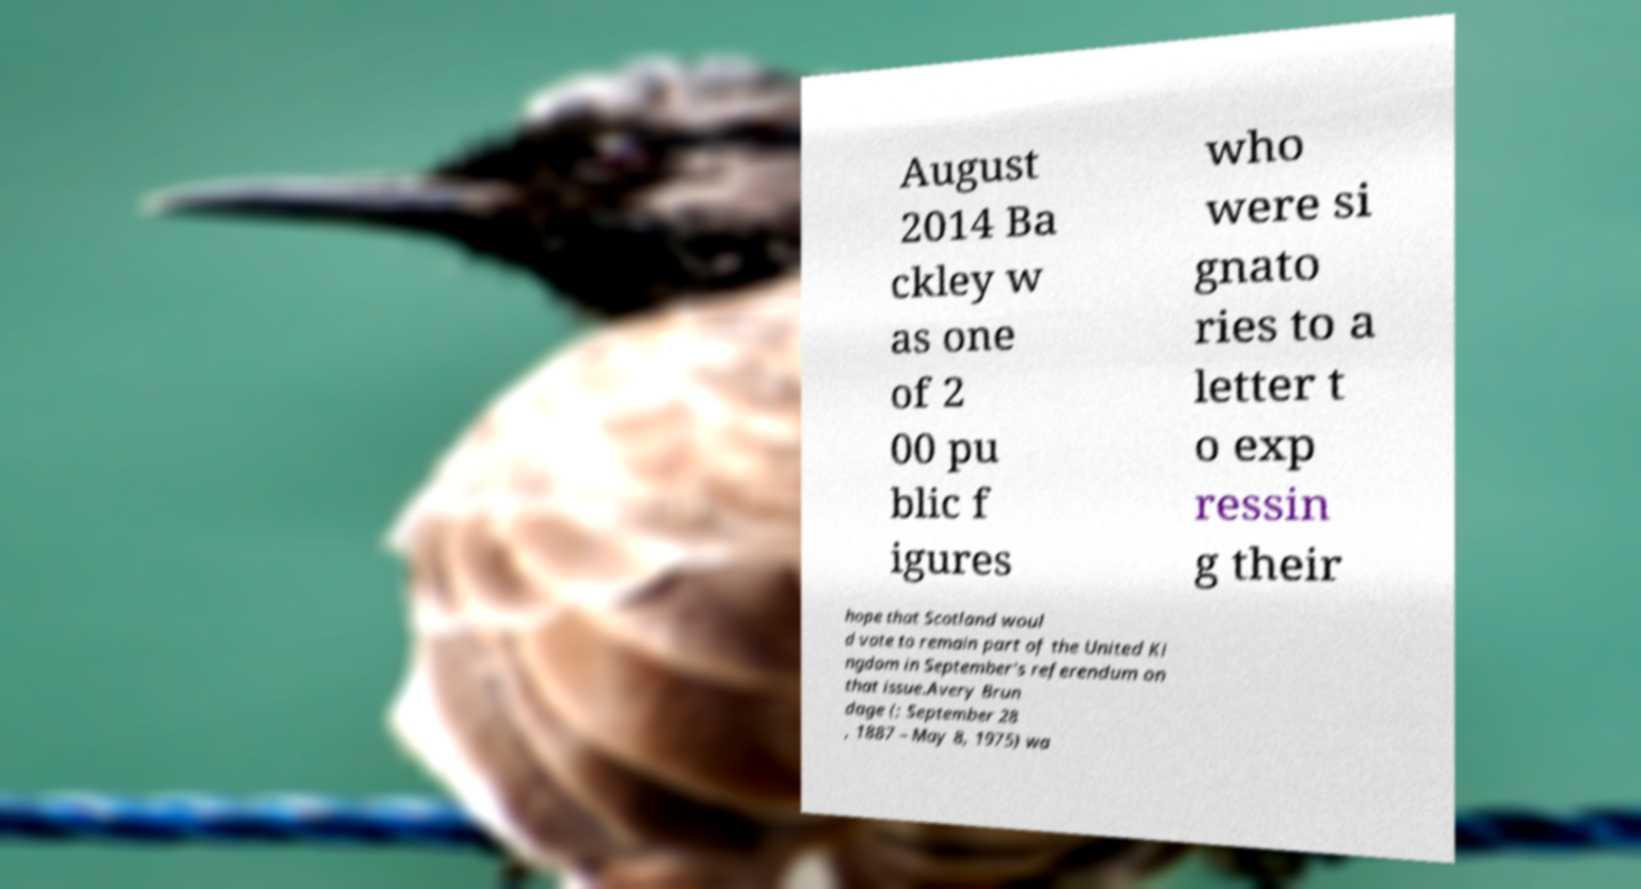Can you read and provide the text displayed in the image?This photo seems to have some interesting text. Can you extract and type it out for me? August 2014 Ba ckley w as one of 2 00 pu blic f igures who were si gnato ries to a letter t o exp ressin g their hope that Scotland woul d vote to remain part of the United Ki ngdom in September's referendum on that issue.Avery Brun dage (; September 28 , 1887 – May 8, 1975) wa 